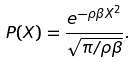Convert formula to latex. <formula><loc_0><loc_0><loc_500><loc_500>P ( X ) = \frac { e ^ { - \rho \beta X ^ { 2 } } } { \sqrt { \pi / \rho \beta } } .</formula> 